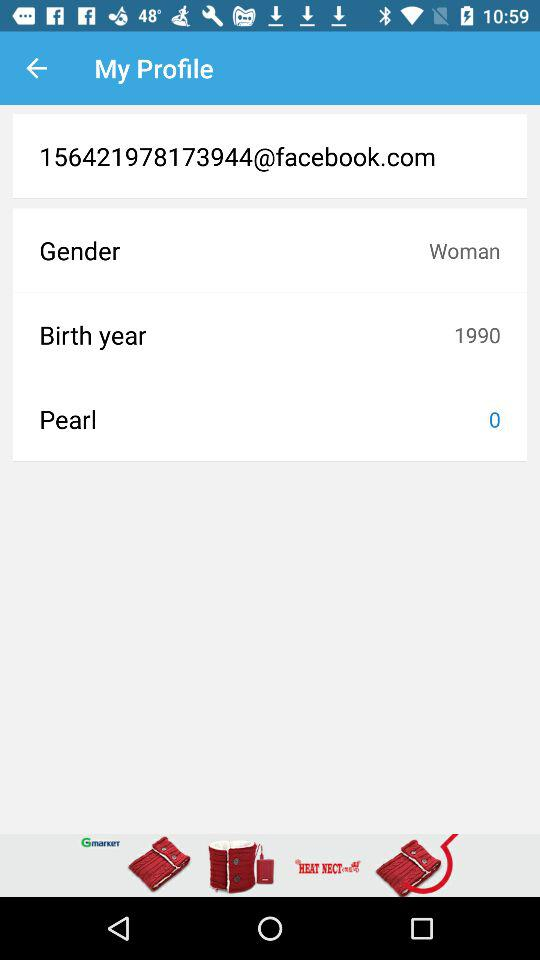What is "Facebook" address of the user? "Facebook" address of the user is "156421978173944@facebook.com". 